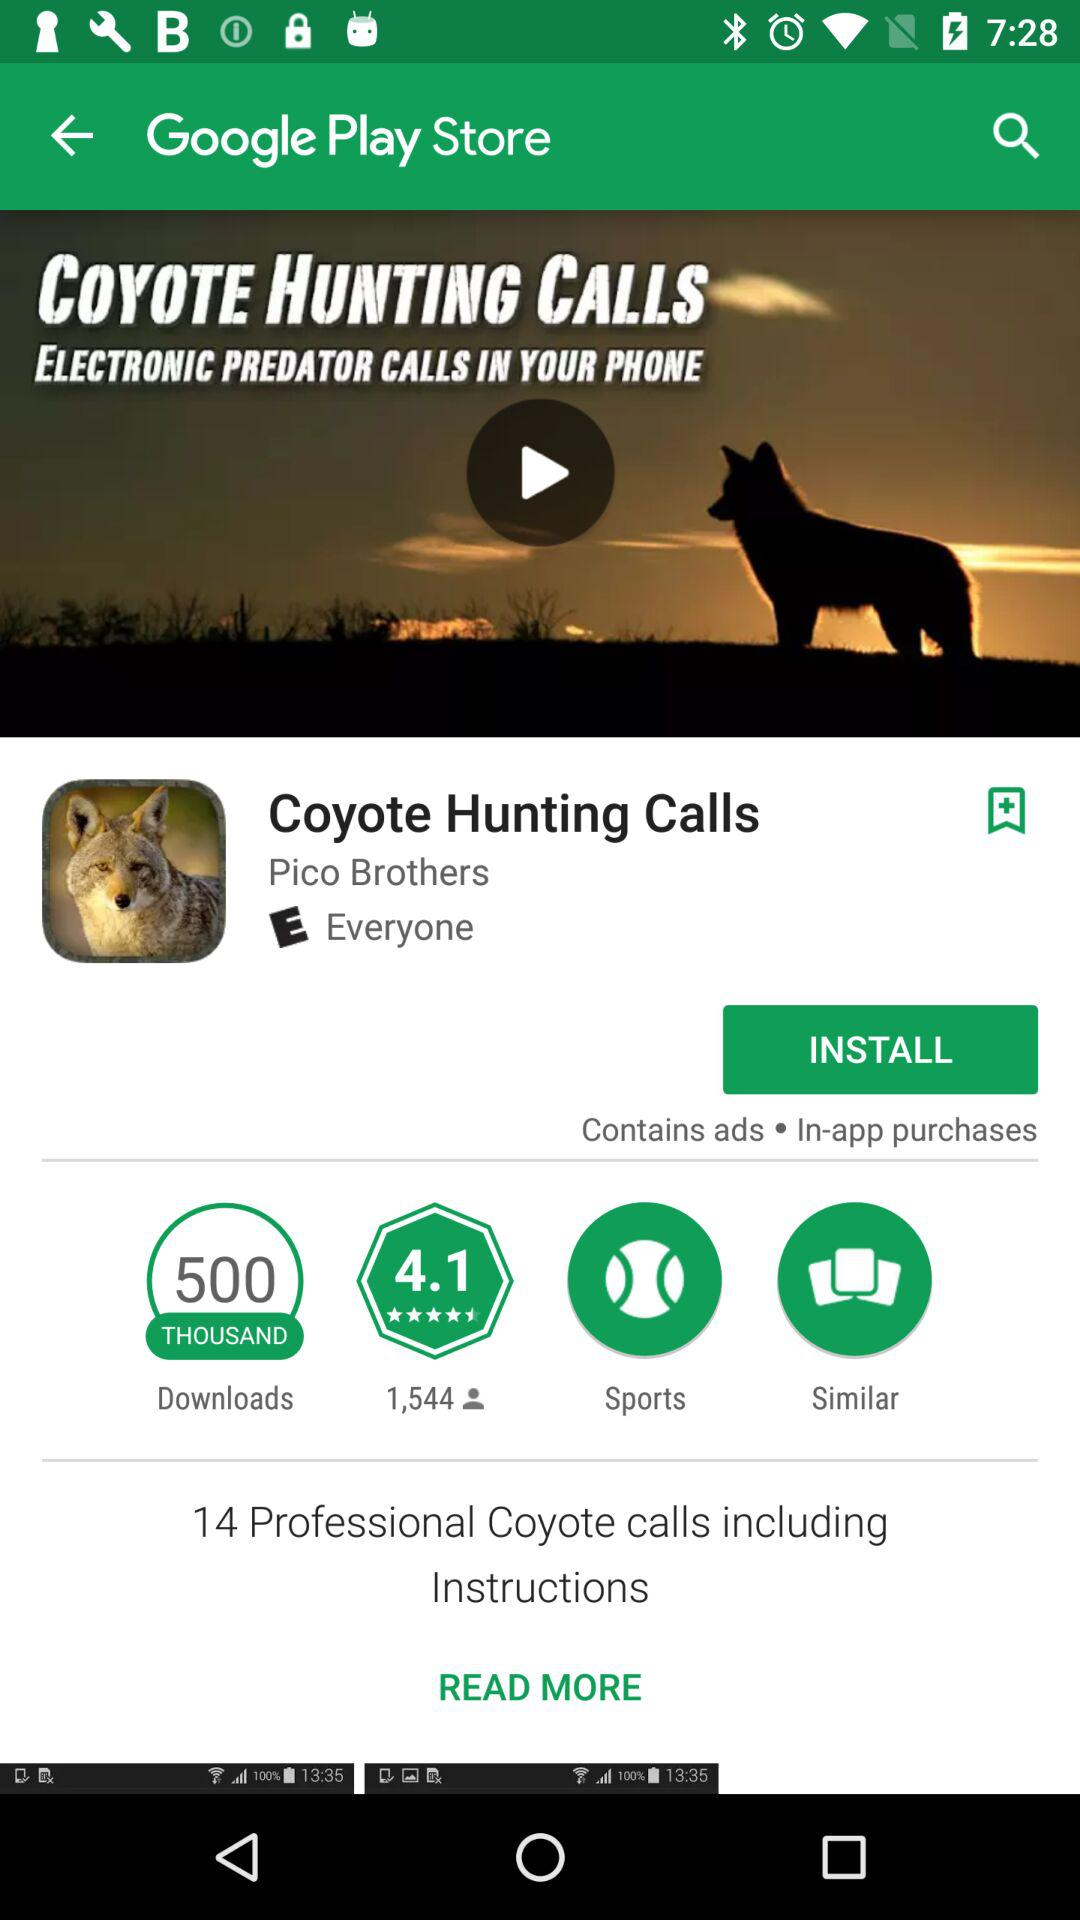What's the number of downloads? The total number of downloads is five hundred thousand. 